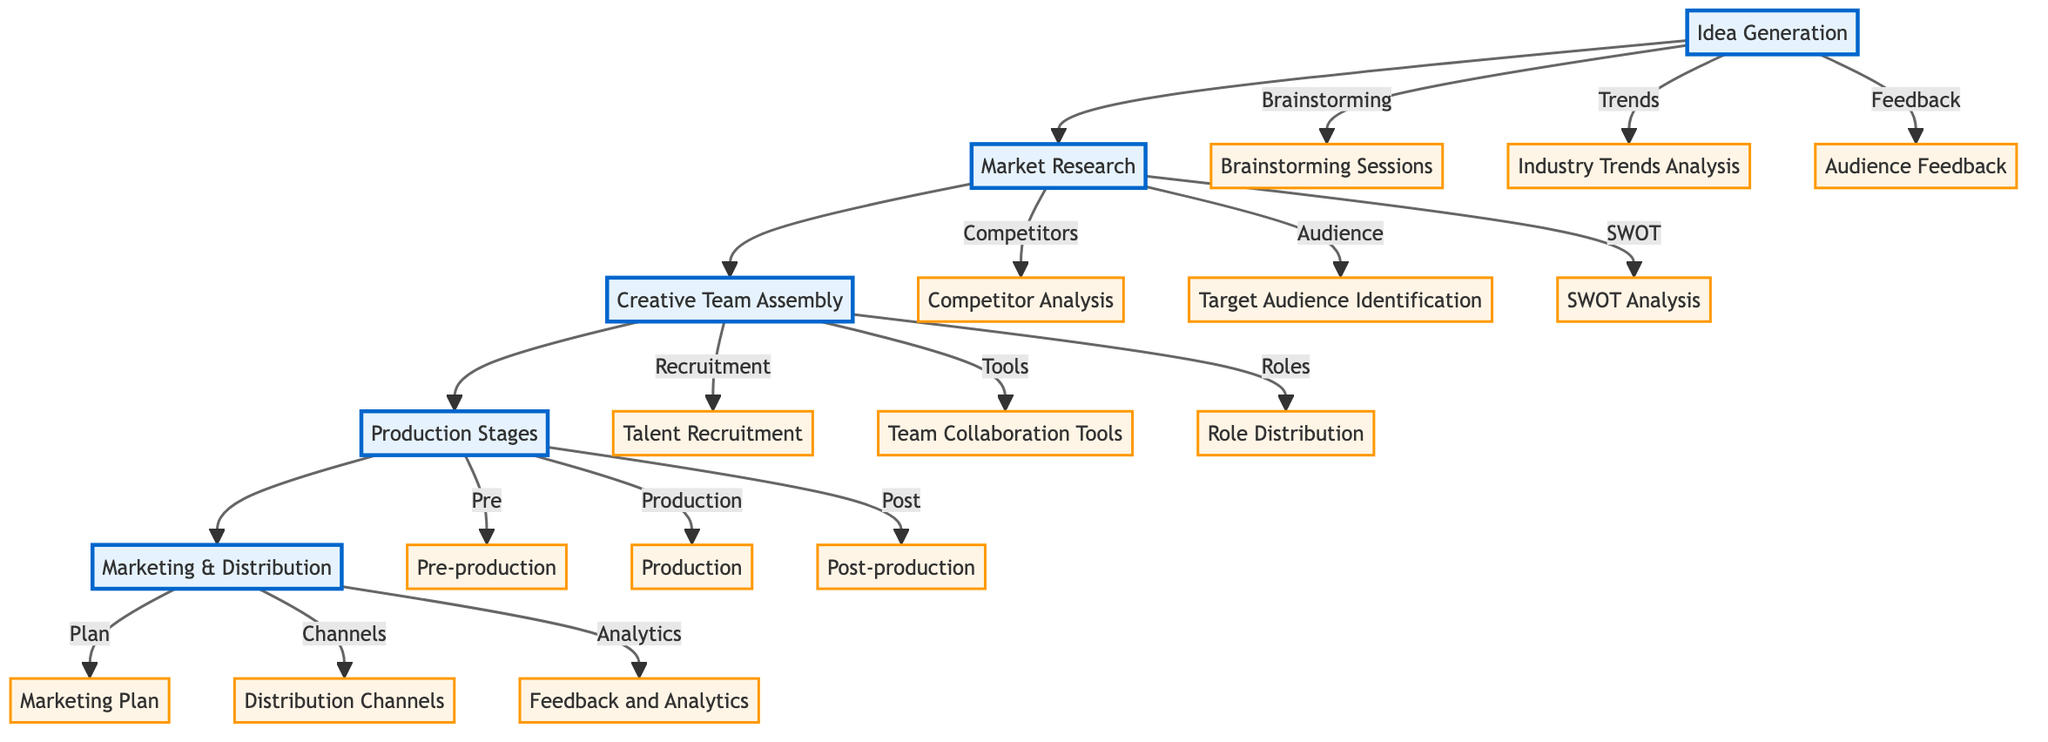What is the first step in the process? The diagram starts with "Idea Generation" as the first block in the sequence, indicating it is the initial step in the content development strategy.
Answer: Idea Generation How many components are in the "Creative Team Assembly" block? The "Creative Team Assembly" block has three components: Talent Recruitment, Team Collaboration Tools, and Role Distribution.
Answer: 3 What is the relationship between "Market Research" and "Creative Team Assembly"? "Market Research" flows directly into "Creative Team Assembly," indicating that the insights gained from market research will be used to inform the assembly of the creative team.
Answer: Direct flow Which block comes before "Production Stages"? The diagram shows that "Creative Team Assembly" leads directly into "Production Stages," making it the block that precedes it.
Answer: Creative Team Assembly What is the final stage of the content development process? The last block in the diagram is "Marketing & Distribution," signifying it is the final stage in the strategy.
Answer: Marketing & Distribution What are the three key components in "Production Stages"? The "Production Stages" comprises three key components: Pre-production, Production, and Post-production, outlining the full process of content creation.
Answer: Pre-production, Production, Post-production How does audience feedback influence content development? Audience feedback is a crucial component of "Idea Generation," and its insights are used to iterate and improve the ideas generated, directly influencing the direction of content development.
Answer: Influences ideas In "Marketing & Distribution," what is the purpose of the "Feedback and Analytics" component? The "Feedback and Analytics" component monitors performance metrics and audience feedback, allowing the team to refine and improve future content based on this data.
Answer: Refine future content How many total blocks are there in the diagram? There are five main blocks in the diagram: Idea Generation, Market Research, Creative Team Assembly, Production Stages, and Marketing & Distribution.
Answer: 5 